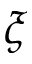Convert formula to latex. <formula><loc_0><loc_0><loc_500><loc_500>\xi</formula> 